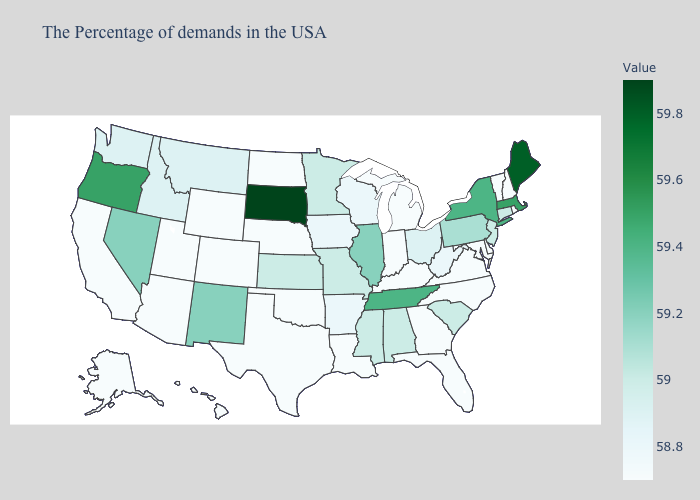Which states have the lowest value in the USA?
Give a very brief answer. Rhode Island, New Hampshire, Vermont, Delaware, Maryland, Virginia, North Carolina, Florida, Georgia, Michigan, Kentucky, Indiana, Louisiana, Nebraska, Oklahoma, Texas, North Dakota, Wyoming, Colorado, Utah, Arizona, California, Alaska, Hawaii. Does Tennessee have a higher value than South Dakota?
Concise answer only. No. Which states have the highest value in the USA?
Short answer required. South Dakota. Does Utah have a lower value than Pennsylvania?
Answer briefly. Yes. Does Pennsylvania have the highest value in the USA?
Concise answer only. No. Which states have the highest value in the USA?
Quick response, please. South Dakota. Does Nevada have a lower value than Tennessee?
Answer briefly. Yes. 